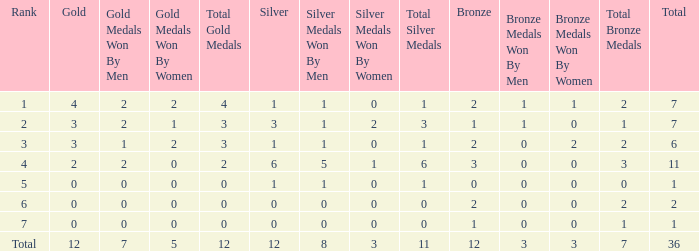What is the largest total for a team with fewer than 12 bronze, 1 silver and 0 gold medals? 1.0. 